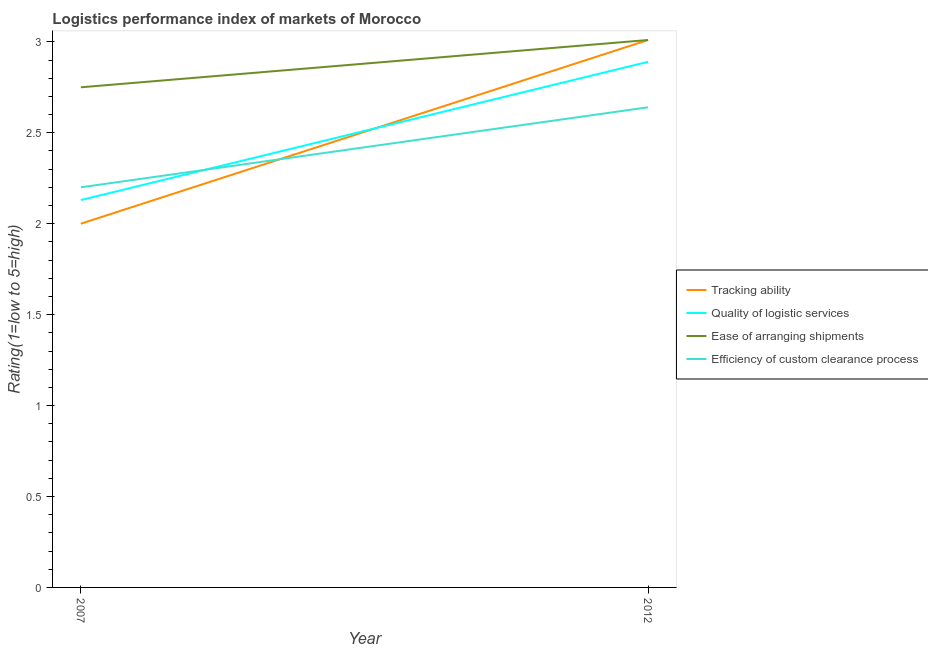How many different coloured lines are there?
Your answer should be very brief. 4. Is the number of lines equal to the number of legend labels?
Offer a very short reply. Yes. What is the lpi rating of ease of arranging shipments in 2007?
Give a very brief answer. 2.75. Across all years, what is the maximum lpi rating of tracking ability?
Keep it short and to the point. 3.01. Across all years, what is the minimum lpi rating of quality of logistic services?
Make the answer very short. 2.13. In which year was the lpi rating of ease of arranging shipments maximum?
Your answer should be very brief. 2012. In which year was the lpi rating of quality of logistic services minimum?
Give a very brief answer. 2007. What is the total lpi rating of quality of logistic services in the graph?
Your answer should be compact. 5.02. What is the difference between the lpi rating of tracking ability in 2007 and that in 2012?
Keep it short and to the point. -1.01. What is the difference between the lpi rating of tracking ability in 2012 and the lpi rating of quality of logistic services in 2007?
Your answer should be very brief. 0.88. What is the average lpi rating of tracking ability per year?
Your answer should be compact. 2.5. In the year 2012, what is the difference between the lpi rating of ease of arranging shipments and lpi rating of quality of logistic services?
Make the answer very short. 0.12. What is the ratio of the lpi rating of efficiency of custom clearance process in 2007 to that in 2012?
Offer a very short reply. 0.83. Does the lpi rating of ease of arranging shipments monotonically increase over the years?
Your response must be concise. Yes. Is the lpi rating of efficiency of custom clearance process strictly greater than the lpi rating of ease of arranging shipments over the years?
Make the answer very short. No. Is the lpi rating of quality of logistic services strictly less than the lpi rating of ease of arranging shipments over the years?
Give a very brief answer. Yes. How many years are there in the graph?
Your answer should be very brief. 2. What is the title of the graph?
Keep it short and to the point. Logistics performance index of markets of Morocco. What is the label or title of the X-axis?
Your answer should be compact. Year. What is the label or title of the Y-axis?
Provide a succinct answer. Rating(1=low to 5=high). What is the Rating(1=low to 5=high) of Tracking ability in 2007?
Provide a succinct answer. 2. What is the Rating(1=low to 5=high) in Quality of logistic services in 2007?
Your answer should be compact. 2.13. What is the Rating(1=low to 5=high) in Ease of arranging shipments in 2007?
Your response must be concise. 2.75. What is the Rating(1=low to 5=high) of Tracking ability in 2012?
Offer a very short reply. 3.01. What is the Rating(1=low to 5=high) in Quality of logistic services in 2012?
Make the answer very short. 2.89. What is the Rating(1=low to 5=high) in Ease of arranging shipments in 2012?
Offer a very short reply. 3.01. What is the Rating(1=low to 5=high) of Efficiency of custom clearance process in 2012?
Provide a succinct answer. 2.64. Across all years, what is the maximum Rating(1=low to 5=high) in Tracking ability?
Your response must be concise. 3.01. Across all years, what is the maximum Rating(1=low to 5=high) of Quality of logistic services?
Offer a terse response. 2.89. Across all years, what is the maximum Rating(1=low to 5=high) of Ease of arranging shipments?
Your response must be concise. 3.01. Across all years, what is the maximum Rating(1=low to 5=high) of Efficiency of custom clearance process?
Your answer should be very brief. 2.64. Across all years, what is the minimum Rating(1=low to 5=high) in Quality of logistic services?
Give a very brief answer. 2.13. Across all years, what is the minimum Rating(1=low to 5=high) in Ease of arranging shipments?
Provide a succinct answer. 2.75. Across all years, what is the minimum Rating(1=low to 5=high) of Efficiency of custom clearance process?
Your response must be concise. 2.2. What is the total Rating(1=low to 5=high) of Tracking ability in the graph?
Keep it short and to the point. 5.01. What is the total Rating(1=low to 5=high) in Quality of logistic services in the graph?
Offer a very short reply. 5.02. What is the total Rating(1=low to 5=high) in Ease of arranging shipments in the graph?
Your response must be concise. 5.76. What is the total Rating(1=low to 5=high) of Efficiency of custom clearance process in the graph?
Offer a terse response. 4.84. What is the difference between the Rating(1=low to 5=high) in Tracking ability in 2007 and that in 2012?
Keep it short and to the point. -1.01. What is the difference between the Rating(1=low to 5=high) in Quality of logistic services in 2007 and that in 2012?
Provide a short and direct response. -0.76. What is the difference between the Rating(1=low to 5=high) in Ease of arranging shipments in 2007 and that in 2012?
Ensure brevity in your answer.  -0.26. What is the difference between the Rating(1=low to 5=high) of Efficiency of custom clearance process in 2007 and that in 2012?
Make the answer very short. -0.44. What is the difference between the Rating(1=low to 5=high) in Tracking ability in 2007 and the Rating(1=low to 5=high) in Quality of logistic services in 2012?
Your answer should be very brief. -0.89. What is the difference between the Rating(1=low to 5=high) of Tracking ability in 2007 and the Rating(1=low to 5=high) of Ease of arranging shipments in 2012?
Offer a terse response. -1.01. What is the difference between the Rating(1=low to 5=high) of Tracking ability in 2007 and the Rating(1=low to 5=high) of Efficiency of custom clearance process in 2012?
Your answer should be very brief. -0.64. What is the difference between the Rating(1=low to 5=high) in Quality of logistic services in 2007 and the Rating(1=low to 5=high) in Ease of arranging shipments in 2012?
Offer a very short reply. -0.88. What is the difference between the Rating(1=low to 5=high) in Quality of logistic services in 2007 and the Rating(1=low to 5=high) in Efficiency of custom clearance process in 2012?
Offer a very short reply. -0.51. What is the difference between the Rating(1=low to 5=high) in Ease of arranging shipments in 2007 and the Rating(1=low to 5=high) in Efficiency of custom clearance process in 2012?
Make the answer very short. 0.11. What is the average Rating(1=low to 5=high) in Tracking ability per year?
Your answer should be compact. 2.5. What is the average Rating(1=low to 5=high) in Quality of logistic services per year?
Provide a succinct answer. 2.51. What is the average Rating(1=low to 5=high) in Ease of arranging shipments per year?
Offer a terse response. 2.88. What is the average Rating(1=low to 5=high) of Efficiency of custom clearance process per year?
Make the answer very short. 2.42. In the year 2007, what is the difference between the Rating(1=low to 5=high) of Tracking ability and Rating(1=low to 5=high) of Quality of logistic services?
Make the answer very short. -0.13. In the year 2007, what is the difference between the Rating(1=low to 5=high) in Tracking ability and Rating(1=low to 5=high) in Ease of arranging shipments?
Give a very brief answer. -0.75. In the year 2007, what is the difference between the Rating(1=low to 5=high) in Tracking ability and Rating(1=low to 5=high) in Efficiency of custom clearance process?
Keep it short and to the point. -0.2. In the year 2007, what is the difference between the Rating(1=low to 5=high) in Quality of logistic services and Rating(1=low to 5=high) in Ease of arranging shipments?
Your response must be concise. -0.62. In the year 2007, what is the difference between the Rating(1=low to 5=high) of Quality of logistic services and Rating(1=low to 5=high) of Efficiency of custom clearance process?
Ensure brevity in your answer.  -0.07. In the year 2007, what is the difference between the Rating(1=low to 5=high) in Ease of arranging shipments and Rating(1=low to 5=high) in Efficiency of custom clearance process?
Your answer should be compact. 0.55. In the year 2012, what is the difference between the Rating(1=low to 5=high) of Tracking ability and Rating(1=low to 5=high) of Quality of logistic services?
Keep it short and to the point. 0.12. In the year 2012, what is the difference between the Rating(1=low to 5=high) in Tracking ability and Rating(1=low to 5=high) in Ease of arranging shipments?
Provide a short and direct response. 0. In the year 2012, what is the difference between the Rating(1=low to 5=high) in Tracking ability and Rating(1=low to 5=high) in Efficiency of custom clearance process?
Your answer should be compact. 0.37. In the year 2012, what is the difference between the Rating(1=low to 5=high) of Quality of logistic services and Rating(1=low to 5=high) of Ease of arranging shipments?
Your answer should be very brief. -0.12. In the year 2012, what is the difference between the Rating(1=low to 5=high) in Ease of arranging shipments and Rating(1=low to 5=high) in Efficiency of custom clearance process?
Your response must be concise. 0.37. What is the ratio of the Rating(1=low to 5=high) in Tracking ability in 2007 to that in 2012?
Your answer should be compact. 0.66. What is the ratio of the Rating(1=low to 5=high) of Quality of logistic services in 2007 to that in 2012?
Offer a terse response. 0.74. What is the ratio of the Rating(1=low to 5=high) of Ease of arranging shipments in 2007 to that in 2012?
Your answer should be compact. 0.91. What is the difference between the highest and the second highest Rating(1=low to 5=high) in Tracking ability?
Make the answer very short. 1.01. What is the difference between the highest and the second highest Rating(1=low to 5=high) in Quality of logistic services?
Offer a very short reply. 0.76. What is the difference between the highest and the second highest Rating(1=low to 5=high) of Ease of arranging shipments?
Make the answer very short. 0.26. What is the difference between the highest and the second highest Rating(1=low to 5=high) in Efficiency of custom clearance process?
Your answer should be very brief. 0.44. What is the difference between the highest and the lowest Rating(1=low to 5=high) in Quality of logistic services?
Ensure brevity in your answer.  0.76. What is the difference between the highest and the lowest Rating(1=low to 5=high) in Ease of arranging shipments?
Your answer should be very brief. 0.26. What is the difference between the highest and the lowest Rating(1=low to 5=high) of Efficiency of custom clearance process?
Offer a very short reply. 0.44. 